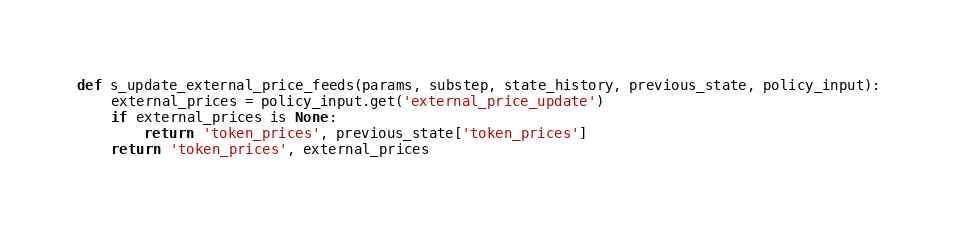<code> <loc_0><loc_0><loc_500><loc_500><_Python_>

def s_update_external_price_feeds(params, substep, state_history, previous_state, policy_input):
    external_prices = policy_input.get('external_price_update')
    if external_prices is None:
        return 'token_prices', previous_state['token_prices']
    return 'token_prices', external_prices

</code> 